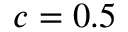Convert formula to latex. <formula><loc_0><loc_0><loc_500><loc_500>c = 0 . 5</formula> 